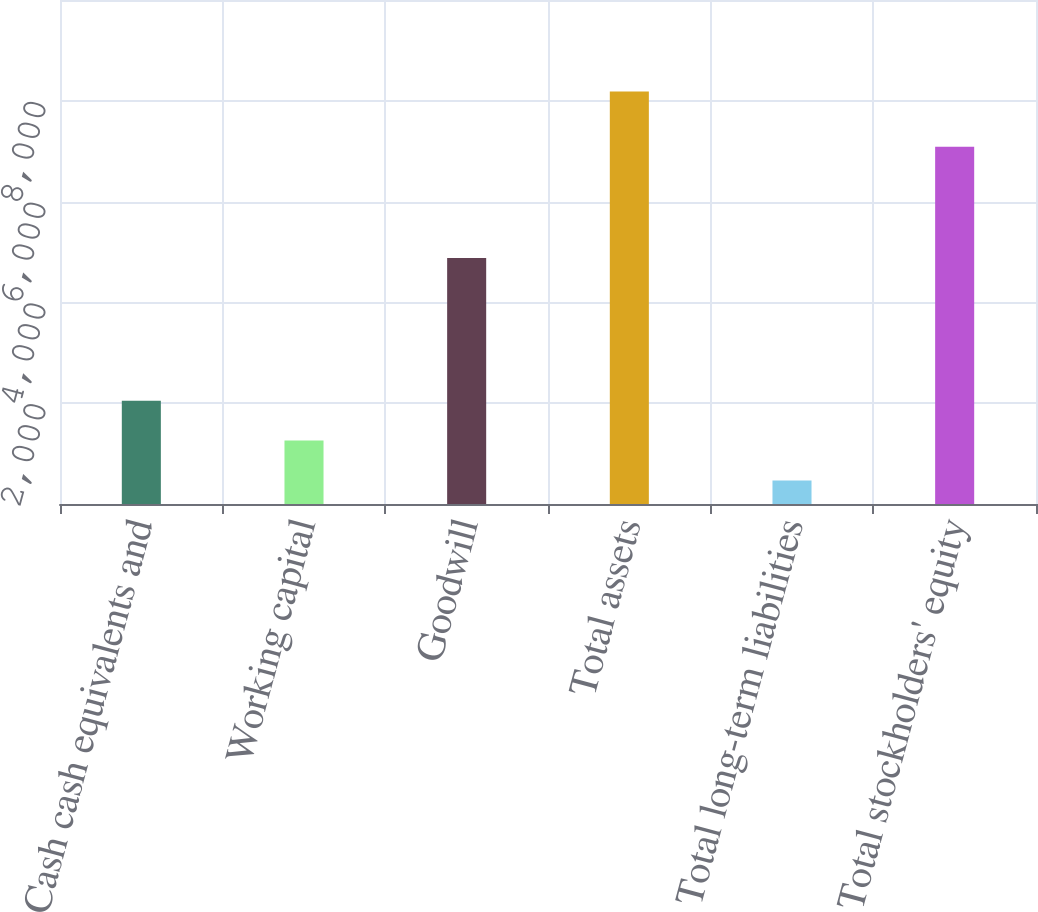Convert chart. <chart><loc_0><loc_0><loc_500><loc_500><bar_chart><fcel>Cash cash equivalents and<fcel>Working capital<fcel>Goodwill<fcel>Total assets<fcel>Total long-term liabilities<fcel>Total stockholders' equity<nl><fcel>2047.1<fcel>1261.4<fcel>4879.7<fcel>8183.6<fcel>468<fcel>7088.2<nl></chart> 